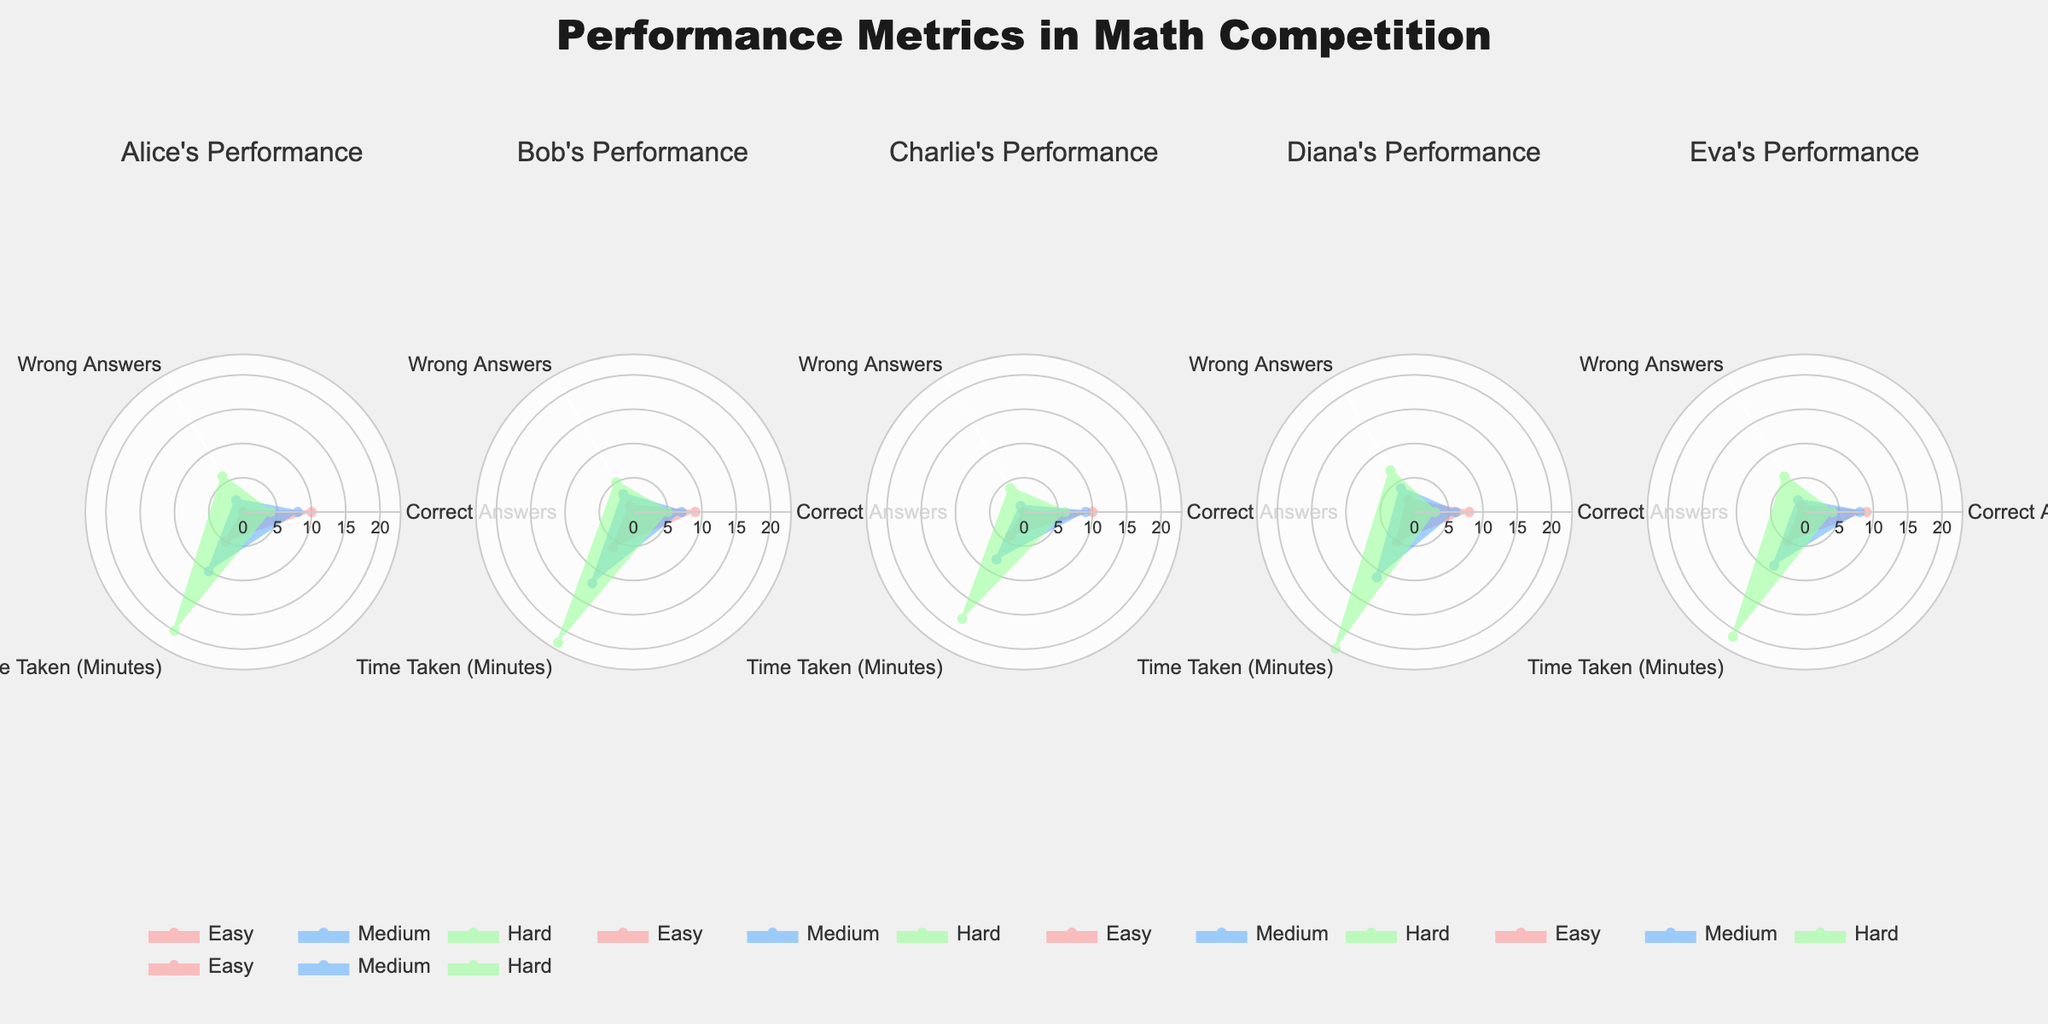What is the primary difference in performance metrics between Alice and Bob on hard problems? Comparing Alice and Bob's performance on hard problems, Alice had 4 correct answers, 6 wrong answers, and took 20 minutes, whereas Bob had 5 correct answers, 5 wrong answers, and took 22 minutes. Therefore, Bob performed slightly better in terms of correct answers and wrong answers but took a longer time.
Answer: Bob had more correct answers and fewer wrong answers, but took more time How do Charlie's correct answers compare across easy, medium, and hard problems? By looking at Charlie's correct answers displayed in the subplots, we see 10 correct answers for easy problems, 9 for medium problems, and 6 for hard problems. Consequently, Charlie's performance in terms of correct answers declines as the problem difficulty increases.
Answer: 10 (Easy), 9 (Medium), 6 (Hard) Which participant has the shortest time taken for easy problems? The subplot for each participant shows the time taken for easy problems. Comparing all of them, Charlie took the shortest time with 4 minutes.
Answer: Charlie What is the sum of wrong answers for Diana across all problems? To calculate the sum of Diana's wrong answers across all difficulties: 2 (Easy) + 4 (Medium) + 7 (Hard) = 13.
Answer: 13 Who has the most balanced performance (similar number of correct and wrong answers) for medium problems? For medium problems, comparing the numbers of correct and wrong answers for each participant: Alice (8 correct, 2 wrong), Bob (7 correct, 3 wrong), Charlie (9 correct, 1 wrong), Diana (6 correct, 4 wrong), Eva (8 correct, 2 wrong). Diana has the most balanced performance with 6 correct and 4 wrong answers.
Answer: Diana Which metrics show the greatest difference for Eva when comparing easy and hard problems? Analyzing Eva's performance in subplots for easy versus hard problems: Easy (9 correct, 1 wrong, 5 minutes) and Hard (4 correct, 6 wrong, 21 minutes). The largest difference is in the number of wrong answers (5 points difference).
Answer: Number of wrong answers What is the average time taken for all participants on medium problems? Summing the times taken by all participants for medium problems: 10, 12, 8, 11, and 9 minutes, and finding the average: (10 + 12 + 8 + 11 + 9) / 5 = 50 / 5 = 10.
Answer: 10 minutes 